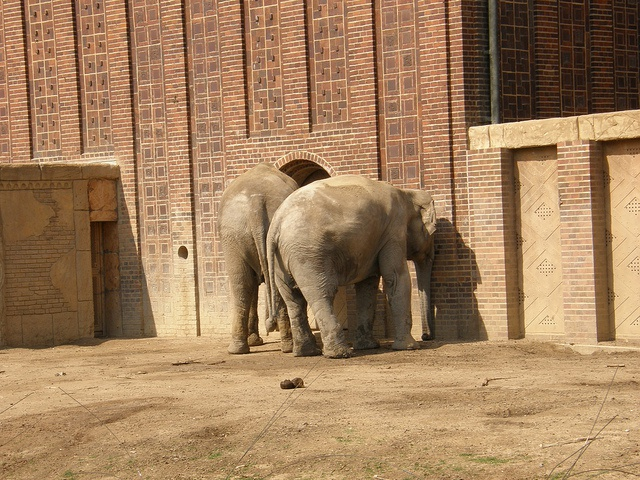Describe the objects in this image and their specific colors. I can see elephant in salmon, maroon, black, and tan tones and elephant in salmon, tan, gray, and maroon tones in this image. 